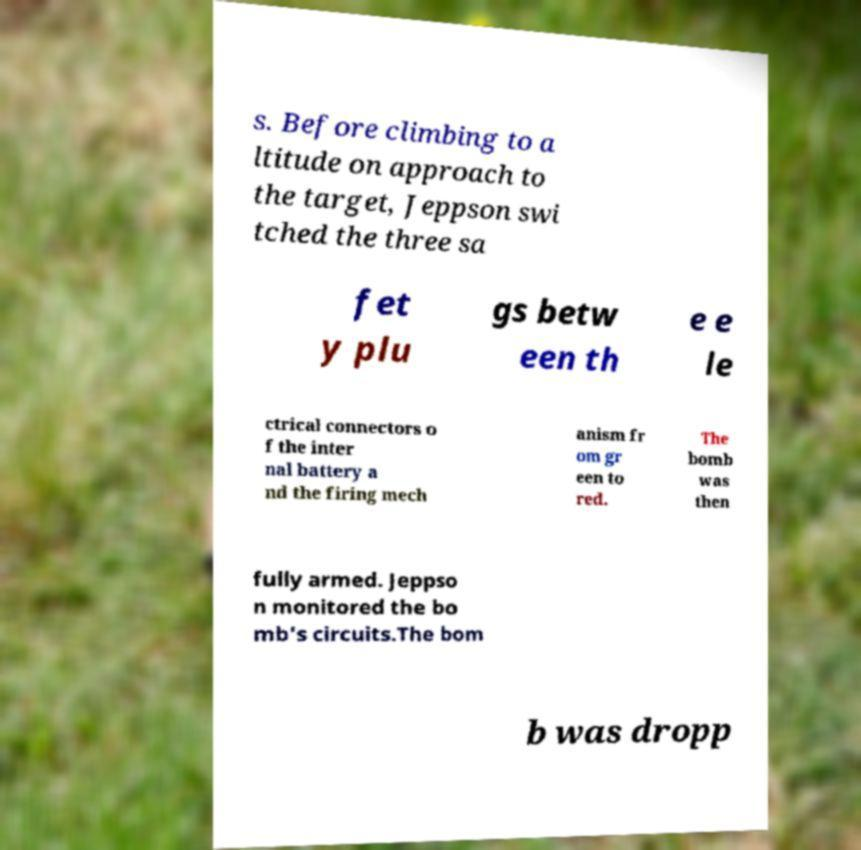Could you assist in decoding the text presented in this image and type it out clearly? s. Before climbing to a ltitude on approach to the target, Jeppson swi tched the three sa fet y plu gs betw een th e e le ctrical connectors o f the inter nal battery a nd the firing mech anism fr om gr een to red. The bomb was then fully armed. Jeppso n monitored the bo mb's circuits.The bom b was dropp 